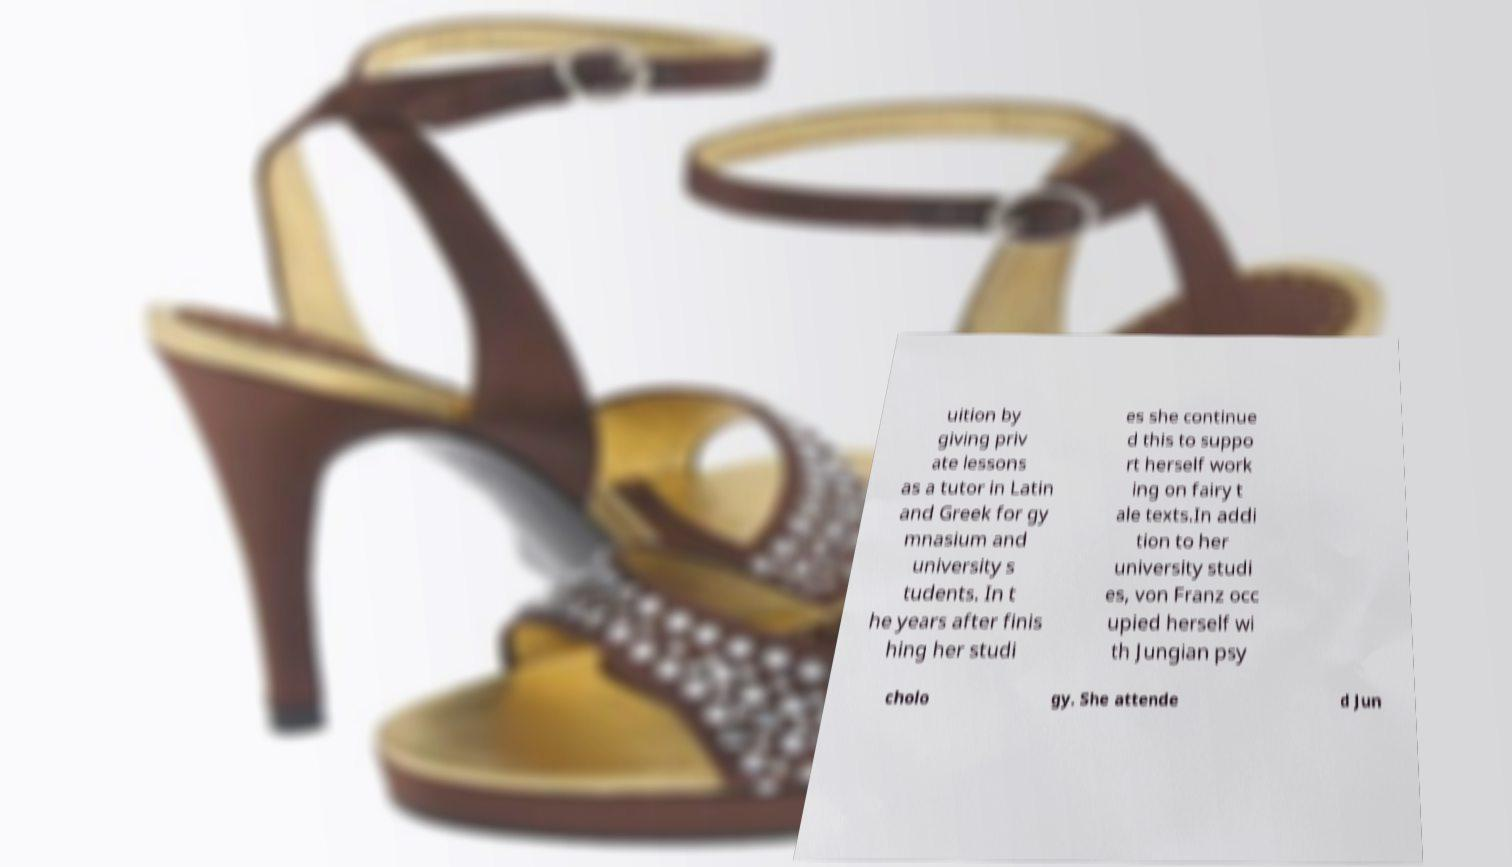Could you assist in decoding the text presented in this image and type it out clearly? uition by giving priv ate lessons as a tutor in Latin and Greek for gy mnasium and university s tudents. In t he years after finis hing her studi es she continue d this to suppo rt herself work ing on fairy t ale texts.In addi tion to her university studi es, von Franz occ upied herself wi th Jungian psy cholo gy. She attende d Jun 